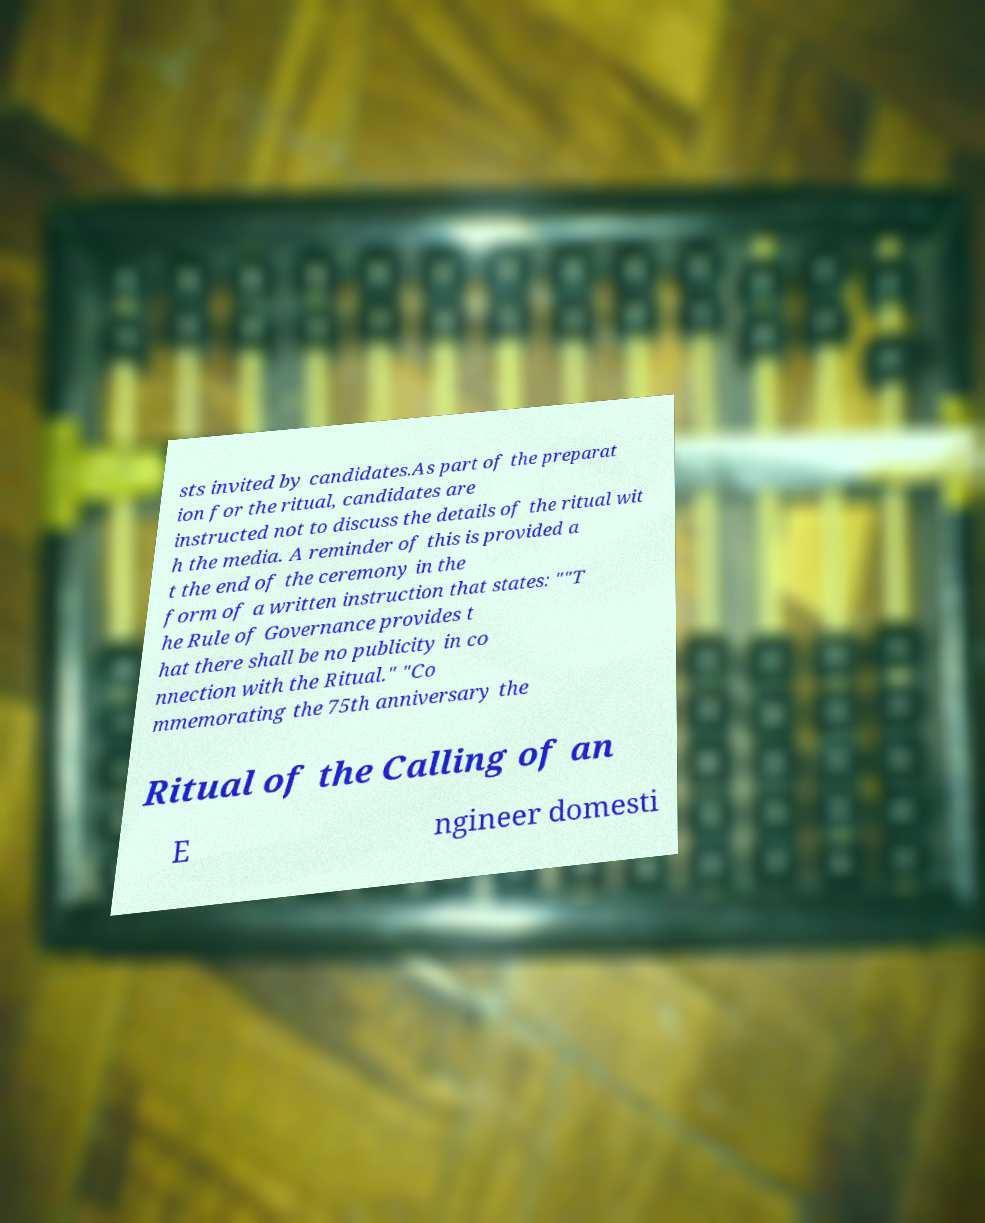Please read and relay the text visible in this image. What does it say? sts invited by candidates.As part of the preparat ion for the ritual, candidates are instructed not to discuss the details of the ritual wit h the media. A reminder of this is provided a t the end of the ceremony in the form of a written instruction that states: ""T he Rule of Governance provides t hat there shall be no publicity in co nnection with the Ritual." "Co mmemorating the 75th anniversary the Ritual of the Calling of an E ngineer domesti 